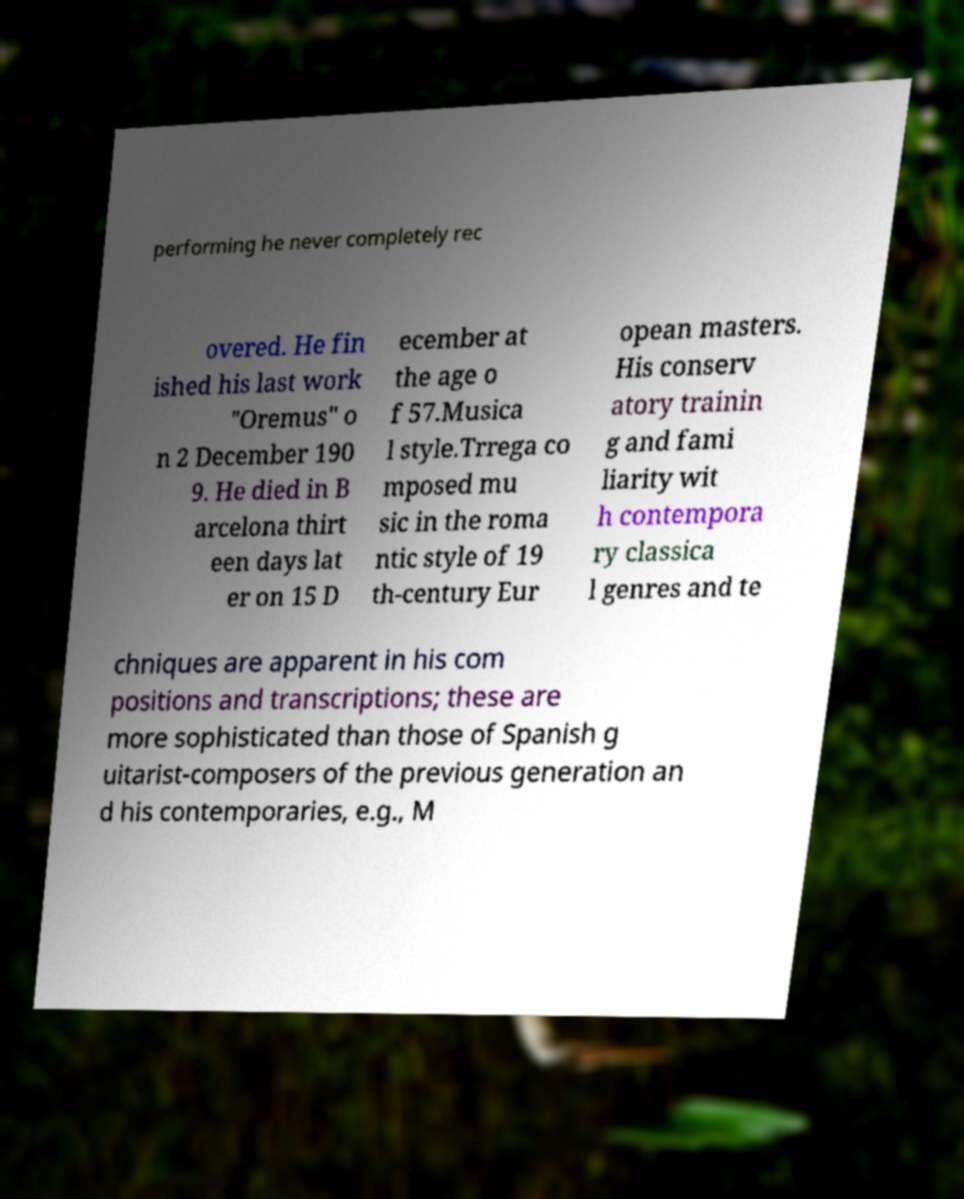Can you read and provide the text displayed in the image?This photo seems to have some interesting text. Can you extract and type it out for me? performing he never completely rec overed. He fin ished his last work "Oremus" o n 2 December 190 9. He died in B arcelona thirt een days lat er on 15 D ecember at the age o f 57.Musica l style.Trrega co mposed mu sic in the roma ntic style of 19 th-century Eur opean masters. His conserv atory trainin g and fami liarity wit h contempora ry classica l genres and te chniques are apparent in his com positions and transcriptions; these are more sophisticated than those of Spanish g uitarist-composers of the previous generation an d his contemporaries, e.g., M 